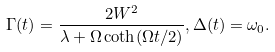Convert formula to latex. <formula><loc_0><loc_0><loc_500><loc_500>\Gamma ( t ) = \frac { 2 W ^ { 2 } } { \lambda + \Omega \coth ( \Omega t / 2 ) } , \Delta ( t ) = \omega _ { 0 } .</formula> 